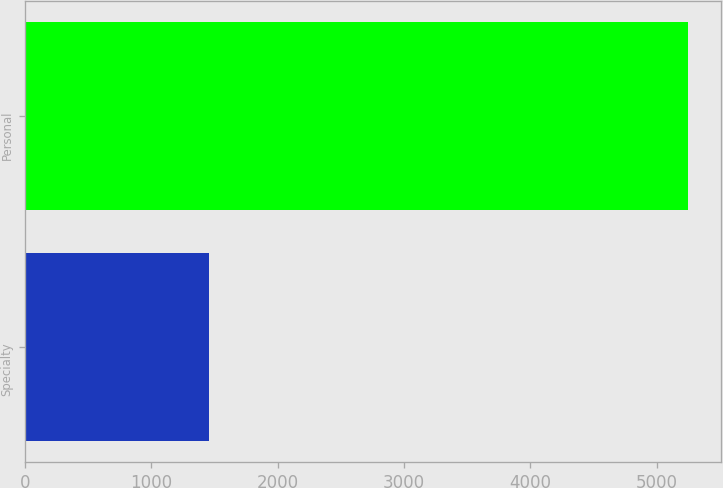Convert chart. <chart><loc_0><loc_0><loc_500><loc_500><bar_chart><fcel>Specialty<fcel>Personal<nl><fcel>1457<fcel>5245<nl></chart> 